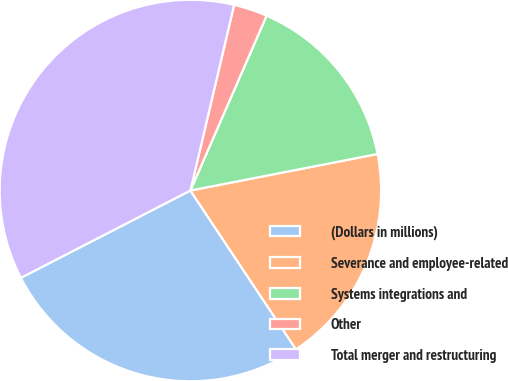Convert chart. <chart><loc_0><loc_0><loc_500><loc_500><pie_chart><fcel>(Dollars in millions)<fcel>Severance and employee-related<fcel>Systems integrations and<fcel>Other<fcel>Total merger and restructuring<nl><fcel>26.77%<fcel>18.73%<fcel>15.39%<fcel>2.86%<fcel>36.25%<nl></chart> 